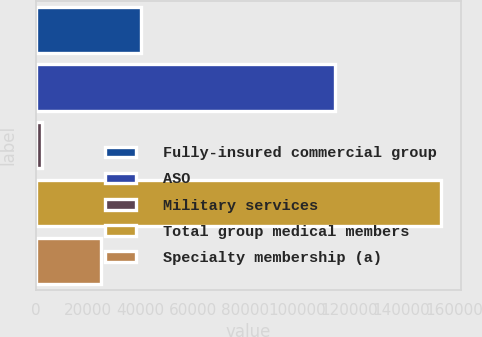Convert chart. <chart><loc_0><loc_0><loc_500><loc_500><bar_chart><fcel>Fully-insured commercial group<fcel>ASO<fcel>Military services<fcel>Total group medical members<fcel>Specialty membership (a)<nl><fcel>40080<fcel>114500<fcel>2300<fcel>155100<fcel>24800<nl></chart> 